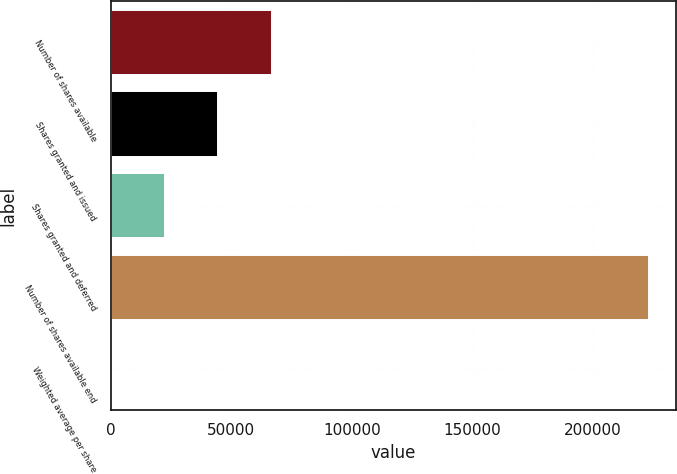Convert chart. <chart><loc_0><loc_0><loc_500><loc_500><bar_chart><fcel>Number of shares available<fcel>Shares granted and issued<fcel>Shares granted and deferred<fcel>Number of shares available end<fcel>Weighted average per share<nl><fcel>66964.8<fcel>44651.8<fcel>22338.8<fcel>223156<fcel>25.77<nl></chart> 